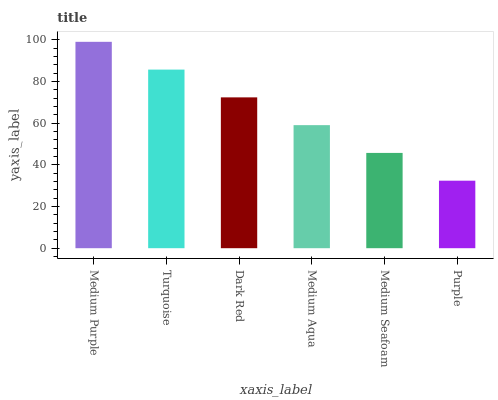Is Purple the minimum?
Answer yes or no. Yes. Is Medium Purple the maximum?
Answer yes or no. Yes. Is Turquoise the minimum?
Answer yes or no. No. Is Turquoise the maximum?
Answer yes or no. No. Is Medium Purple greater than Turquoise?
Answer yes or no. Yes. Is Turquoise less than Medium Purple?
Answer yes or no. Yes. Is Turquoise greater than Medium Purple?
Answer yes or no. No. Is Medium Purple less than Turquoise?
Answer yes or no. No. Is Dark Red the high median?
Answer yes or no. Yes. Is Medium Aqua the low median?
Answer yes or no. Yes. Is Medium Aqua the high median?
Answer yes or no. No. Is Medium Seafoam the low median?
Answer yes or no. No. 